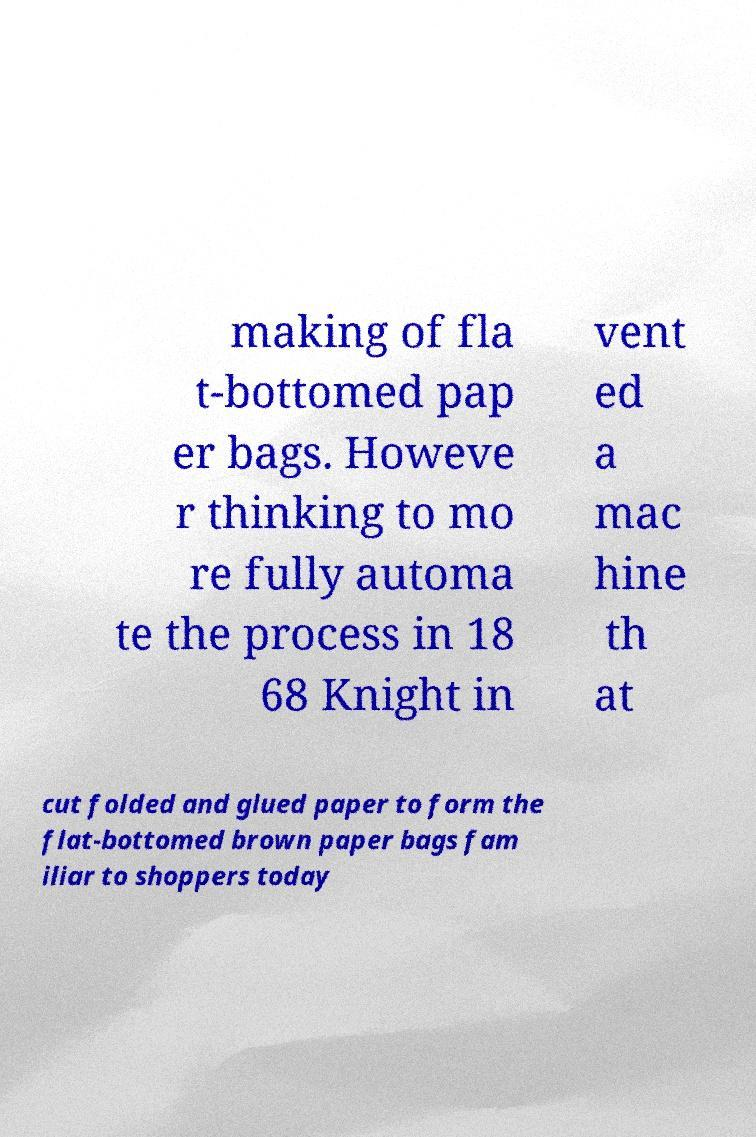Can you read and provide the text displayed in the image?This photo seems to have some interesting text. Can you extract and type it out for me? making of fla t-bottomed pap er bags. Howeve r thinking to mo re fully automa te the process in 18 68 Knight in vent ed a mac hine th at cut folded and glued paper to form the flat-bottomed brown paper bags fam iliar to shoppers today 